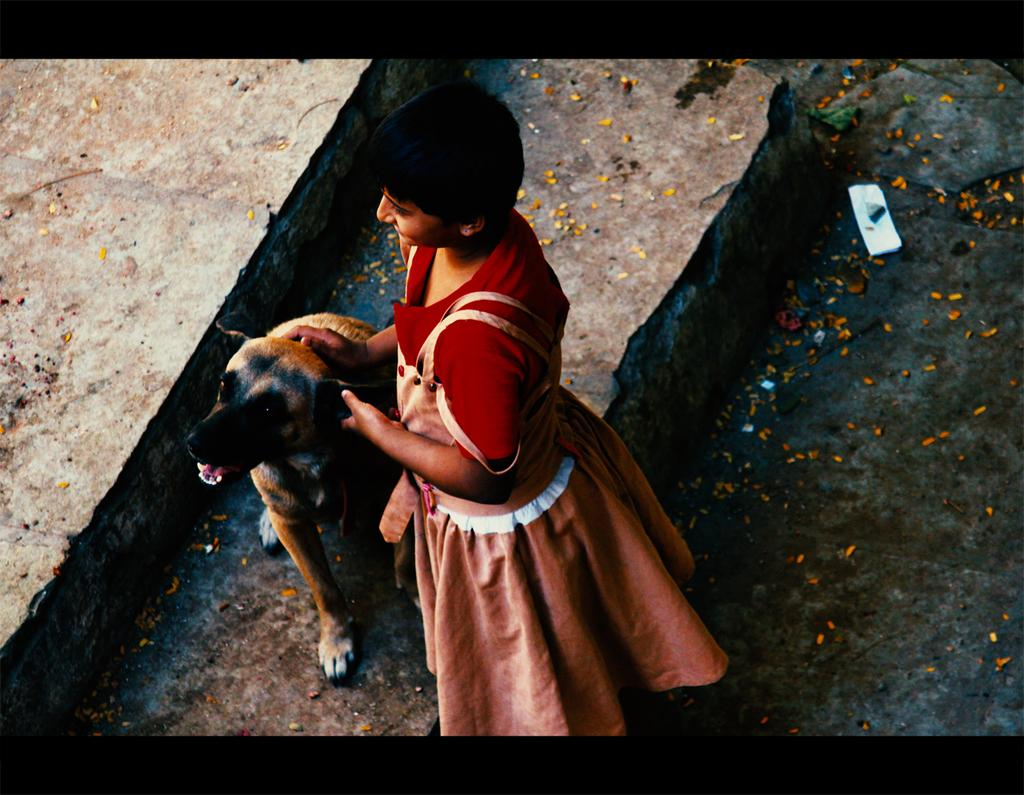What type of setting is depicted in the image? The image has an outside view. Can you describe the person in the image? There is a person standing in the image, and she is wearing clothes. What is the person doing in the image? The person is holding a dog with her hand. What room can be seen in the image? There is no room visible in the image, as it is an outside view. Can you describe the star that is shining in the image? There is no star present in the image; it is an outside view with a person holding a dog. 